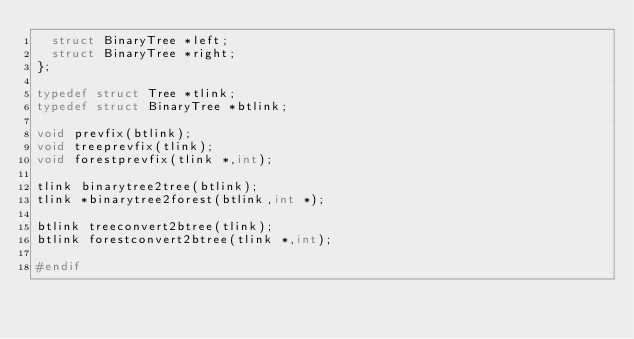Convert code to text. <code><loc_0><loc_0><loc_500><loc_500><_C_>	struct BinaryTree *left;
	struct BinaryTree *right;
};

typedef struct Tree *tlink;
typedef struct BinaryTree *btlink;

void prevfix(btlink);
void treeprevfix(tlink);
void forestprevfix(tlink *,int);

tlink binarytree2tree(btlink);
tlink *binarytree2forest(btlink,int *);

btlink treeconvert2btree(tlink);
btlink forestconvert2btree(tlink *,int);

#endif</code> 